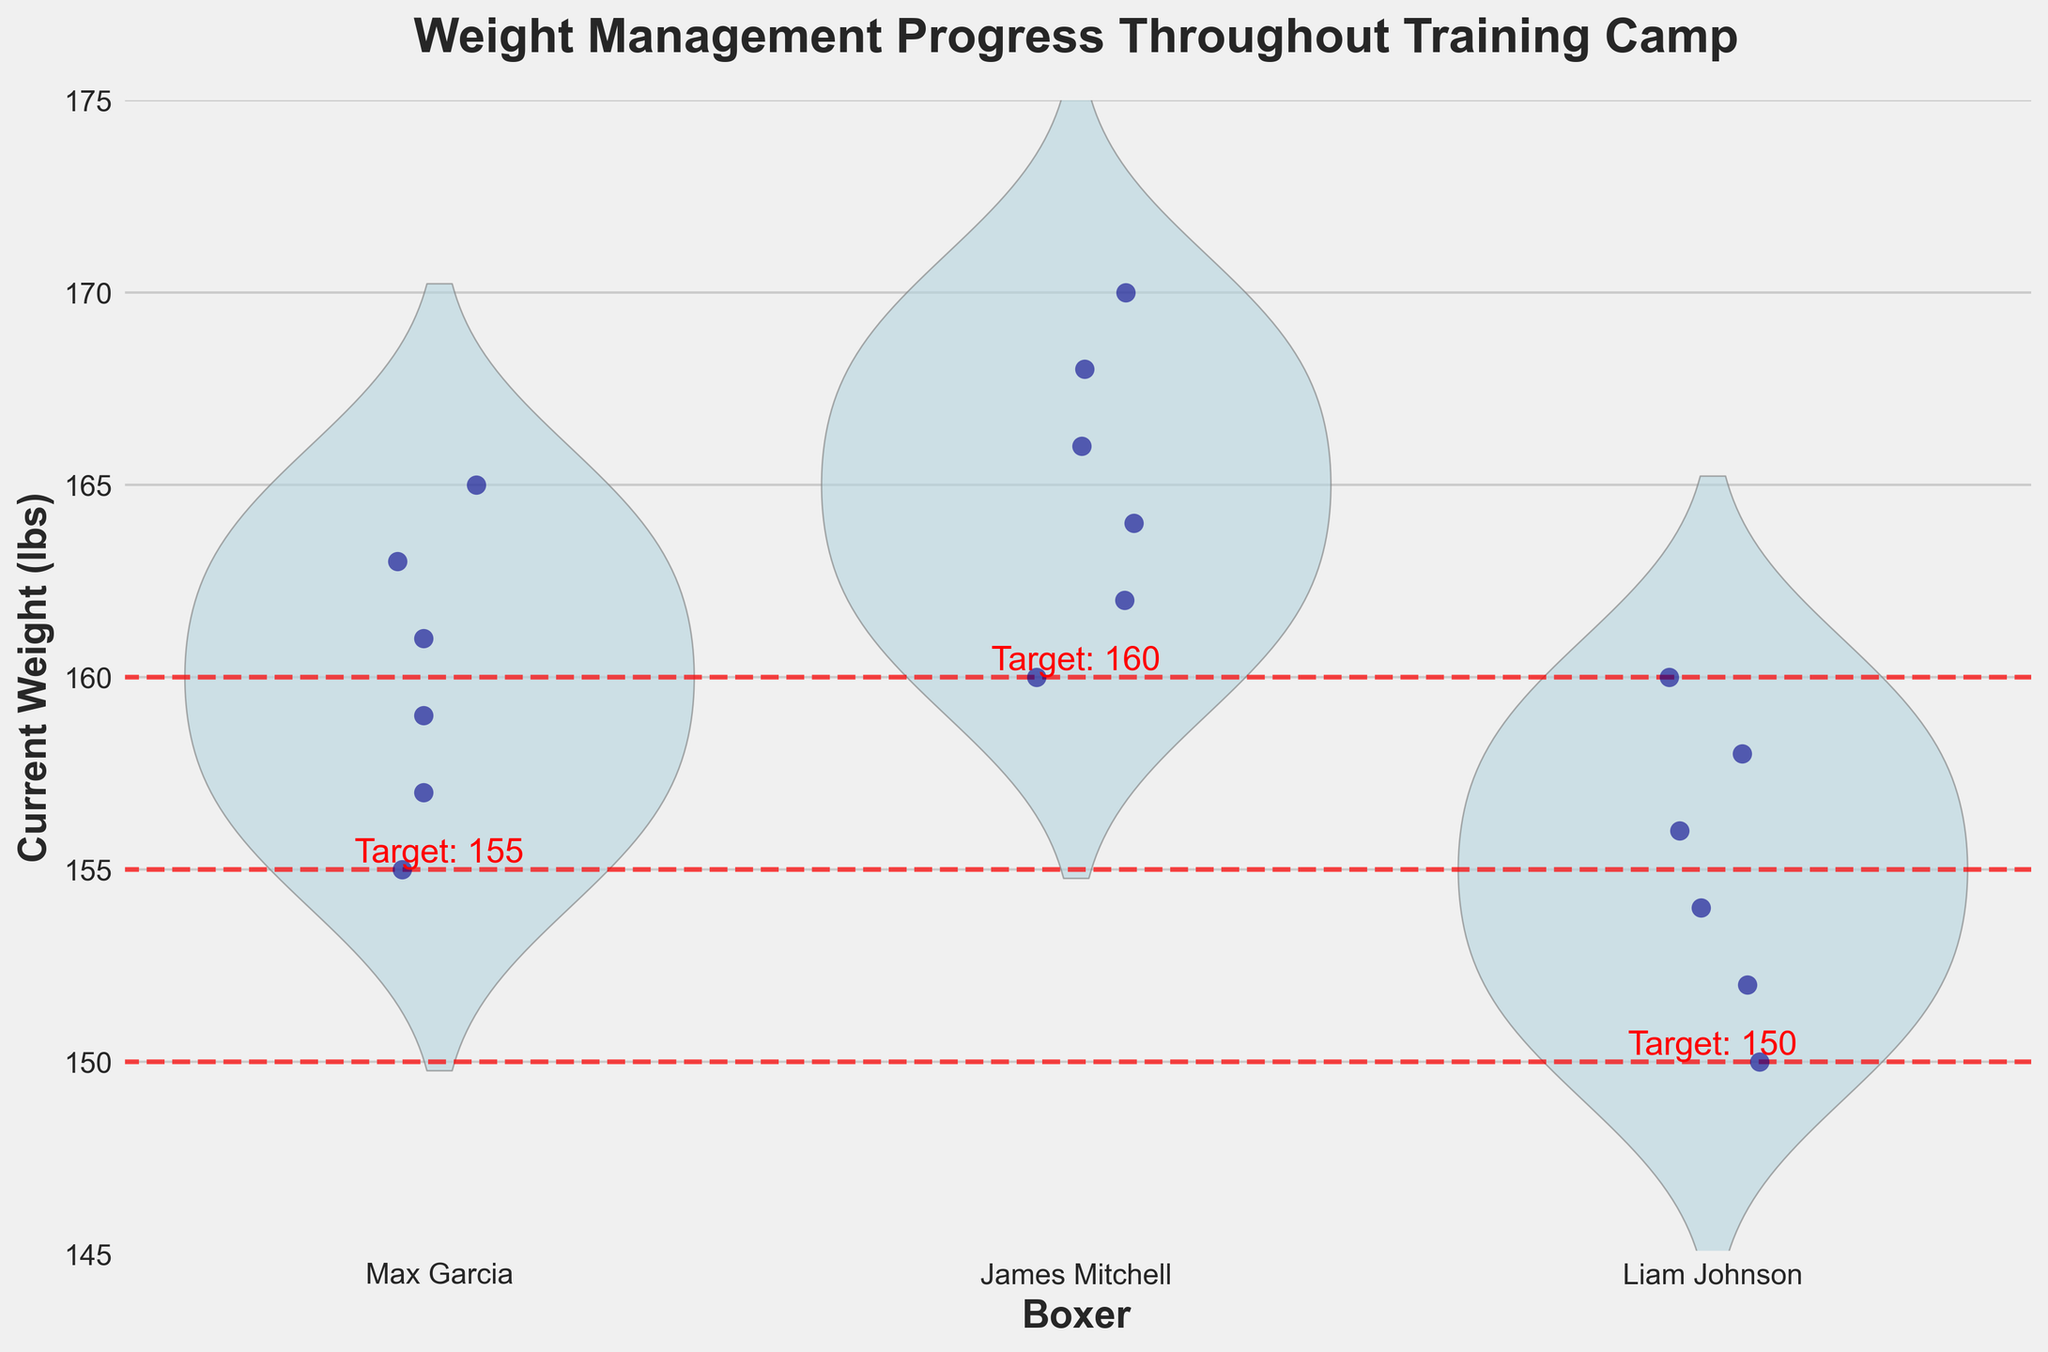what is the title of the chart? The title of the chart is displayed at the top, written in bold and large font, stating what the chart is about.
Answer: Weight Management Progress Throughout Training Camp How many boxers are represented in the chart? The chart shows the different boxes on the x-axis labeled with the boxers' names. By counting these labels, we can determine the number of boxers.
Answer: 3 What is the target weight for James Mitchell? The chart includes a dashed red line for each boxer indicating their target weight. By looking for the red dashed line under James Mitchell’s data points, we can identify his target weight.
Answer: 160 lbs At which week did Max Garcia hit his target weight? The strip plot points in the chart can be inspected week-by-week to see when Max Garcia's weight matches his target weight of 155 lbs.
Answer: Week 6 Who has the largest weight difference from their target weight in Week 1? First, identify the weights and target weights for each boxer during Week 1. Compare the absolute differences between current and target weights to determine the largest.
Answer: James Mitchell What’s the average current weight of Liam Johnson throughout the training camp? Sum all of Liam Johnson’s current weights (160, 158, 156, 154, 152, 150) and divide by the number of weeks (6) to find the average.
Answer: 155 lbs Which boxer showed the most consistent weight trend towards their target weight? Determine consistency by analyzing the spread and direction of the strip plot points; look for the boxer with the most linear and closely grouped points moving toward the target weight line.
Answer: Max Garcia How does the weight variance of James Mitchell compare from Week 1 to Week 6? Examine the spread of points for James Mitchell, noting whether the points are moving closer together (indicating decreasing variance) or farther apart.
Answer: Decreased Between Max Garcia and Liam Johnson, who had a more gradual weight decline? Compare the slopes of the weight reduction from Week 1 to Week 6 for both boxers. The boxer with the smaller slope has a more gradual decline.
Answer: Liam Johnson What could be inferred if one boxer’s weight fluctuates significantly compared to others? Analyze the dispersion and jitter of the weight points for each boxer. Greater fluctuation implies less consistent weight management.
Answer: Less consistent weight management 